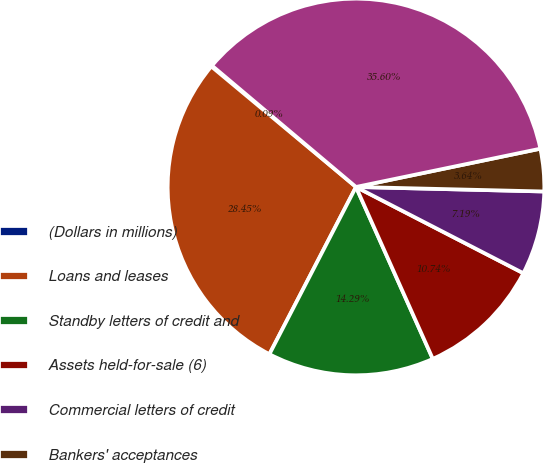Convert chart to OTSL. <chart><loc_0><loc_0><loc_500><loc_500><pie_chart><fcel>(Dollars in millions)<fcel>Loans and leases<fcel>Standby letters of credit and<fcel>Assets held-for-sale (6)<fcel>Commercial letters of credit<fcel>Bankers' acceptances<fcel>Total commercial credit<nl><fcel>0.09%<fcel>28.45%<fcel>14.29%<fcel>10.74%<fcel>7.19%<fcel>3.64%<fcel>35.6%<nl></chart> 